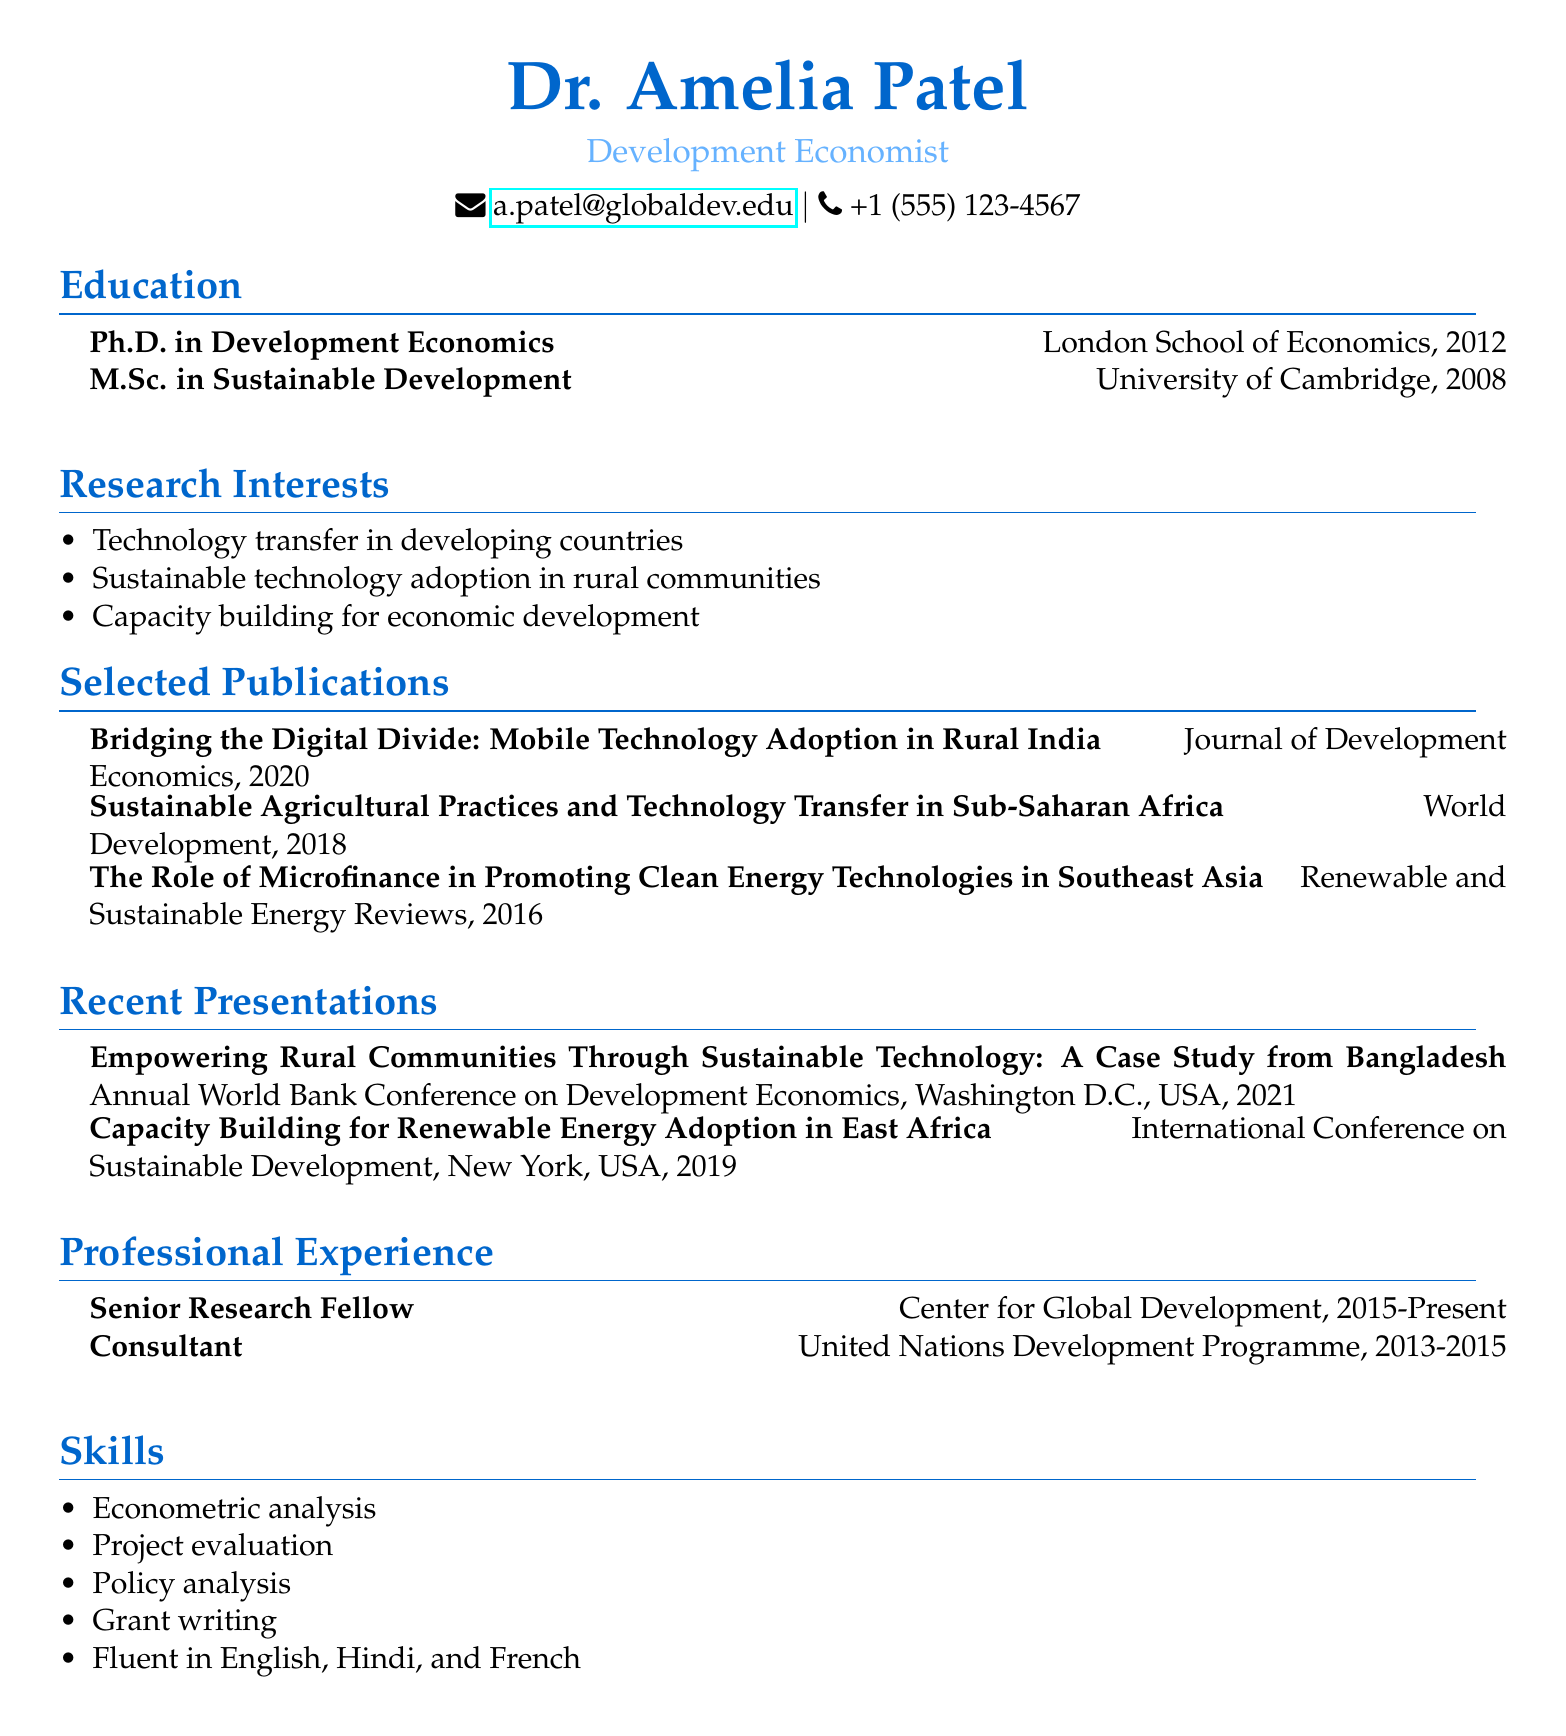What is the name of the individual? The first line of the document provides the name of the individual, which is mentioned prominently.
Answer: Dr. Amelia Patel What is the title listed under the individual's name? The title is stated immediately beneath the name in the document, providing a professional designation.
Answer: Development Economist In what year did Dr. Patel complete her Ph.D.? The education section of the document states the year when the Ph.D. was awarded.
Answer: 2012 How many publications are listed in the document? The publications section details the number of written works by the individual, which can be counted directly.
Answer: 3 What was the topic of the 2021 presentation? The presentation section specifies the title of the presentation made by Dr. Patel in 2021, signaling its topic.
Answer: Empowering Rural Communities Through Sustainable Technology: A Case Study from Bangladesh Which institution is Dr. Patel affiliated with as a Senior Research Fellow? The professional experience section mentions the institution where Dr. Patel holds the position of Senior Research Fellow.
Answer: Center for Global Development What language does Dr. Patel speak fluently alongside English and Hindi? The skills section lists the languages Dr. Patel is fluent in, indicating her multilingual abilities.
Answer: French What is Dr. Patel's research interest related to technology? One of the research interests explicitly addresses technology in the context of developing countries and rural communities.
Answer: Sustainable technology adoption in rural communities What is the duration of Dr. Patel's position as a Senior Research Fellow? The professional experience section indicates the time period she has been in this role.
Answer: 2015-Present 